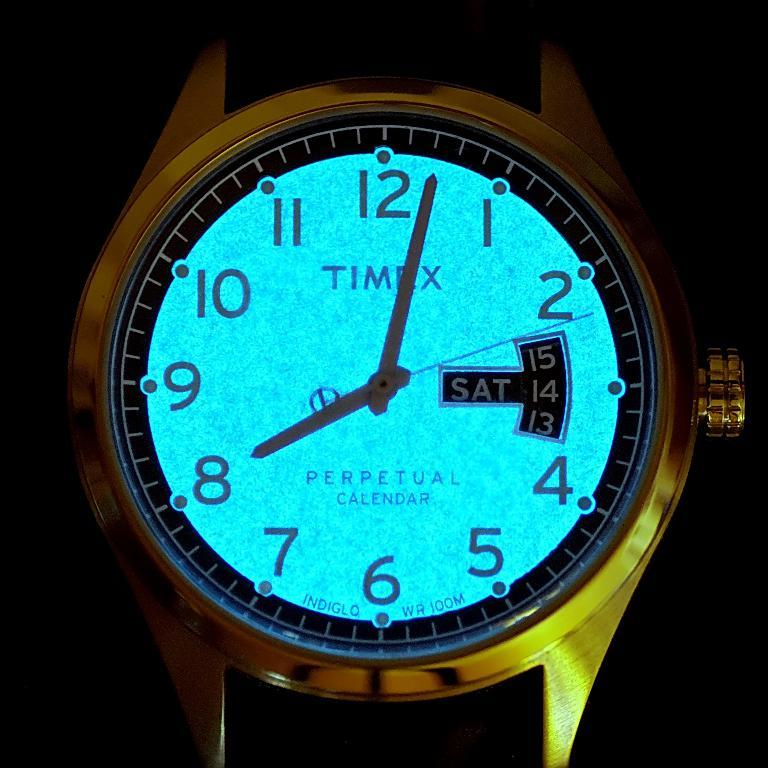<image>
Summarize the visual content of the image. A Timex watch with a perpetual calendar is glowing bright blue. 